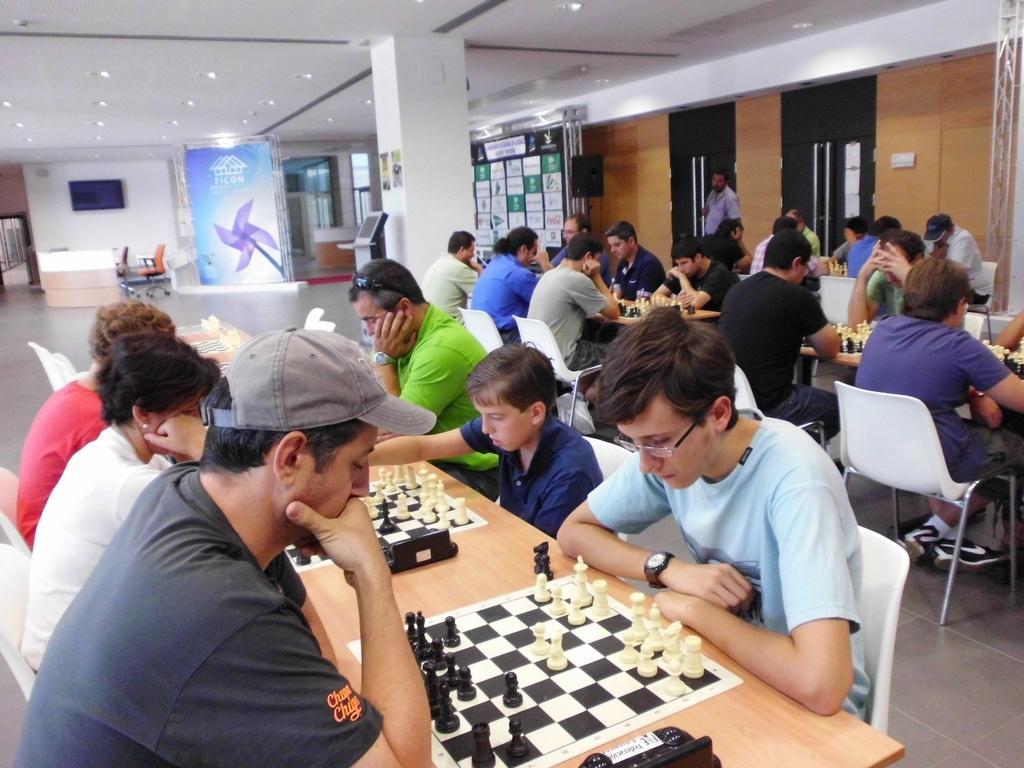Can you describe this image briefly? In the image there are few people sitting around the tables and on the tables there are chess boards and in the background there is a banner, beside that there is an empty chair and in between the room there is a pillar and in front of the pillar there is some gadget. On the right side there are two doors and in front of the door there is a speaker. 